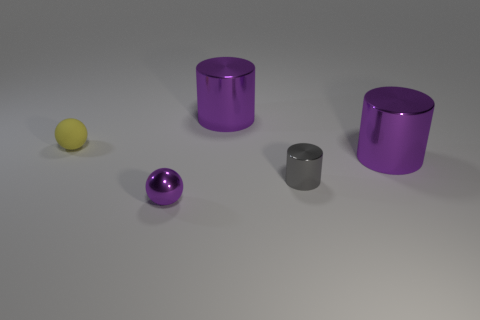Is the color of the sphere behind the shiny sphere the same as the big object in front of the tiny matte thing?
Offer a very short reply. No. Are there any other things that have the same color as the small matte thing?
Offer a terse response. No. Are there fewer purple cylinders that are to the left of the tiny yellow object than yellow metal cylinders?
Ensure brevity in your answer.  No. What number of large purple metal cylinders are there?
Offer a very short reply. 2. There is a rubber thing; is its shape the same as the big metallic thing that is behind the yellow thing?
Offer a very short reply. No. Are there fewer small purple things behind the tiny shiny cylinder than gray cylinders to the left of the yellow sphere?
Keep it short and to the point. No. Are there any other things that are the same shape as the small purple metallic object?
Give a very brief answer. Yes. Do the small gray thing and the tiny purple thing have the same shape?
Give a very brief answer. No. Is there any other thing that is made of the same material as the tiny gray thing?
Provide a succinct answer. Yes. What is the size of the purple ball?
Keep it short and to the point. Small. 